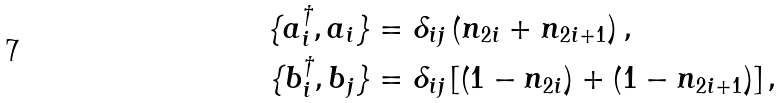<formula> <loc_0><loc_0><loc_500><loc_500>\{ a _ { i } ^ { \dagger } , a _ { i } \} & = \delta _ { i j } \left ( n _ { 2 i } + n _ { 2 i + 1 } \right ) , \\ \{ b _ { i } ^ { \dagger } , b _ { j } \} & = \delta _ { i j } \left [ \left ( 1 - n _ { 2 i } \right ) + \left ( 1 - n _ { 2 i + 1 } \right ) \right ] ,</formula> 